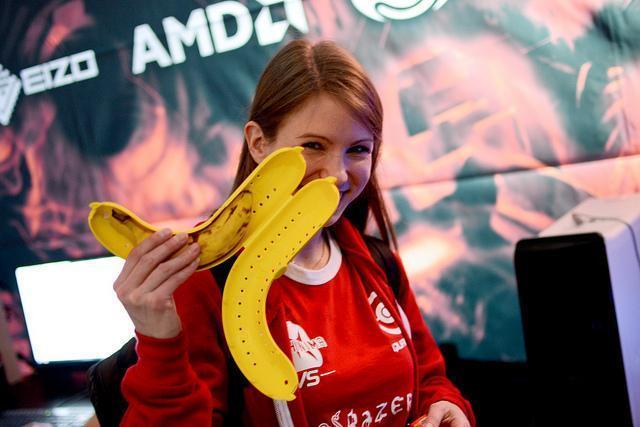How many birds are in the air flying?
Give a very brief answer. 0. 